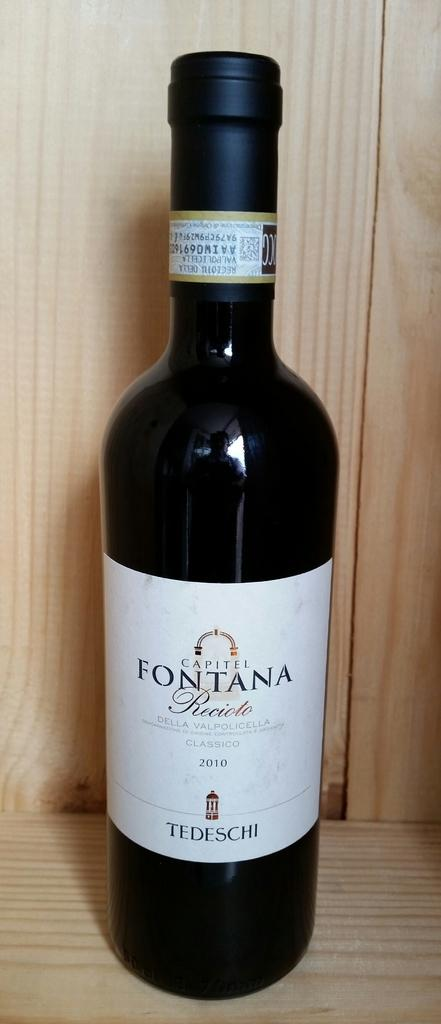<image>
Present a compact description of the photo's key features. A bottle of alcohol from the brand Fontana is on a wooden table. 